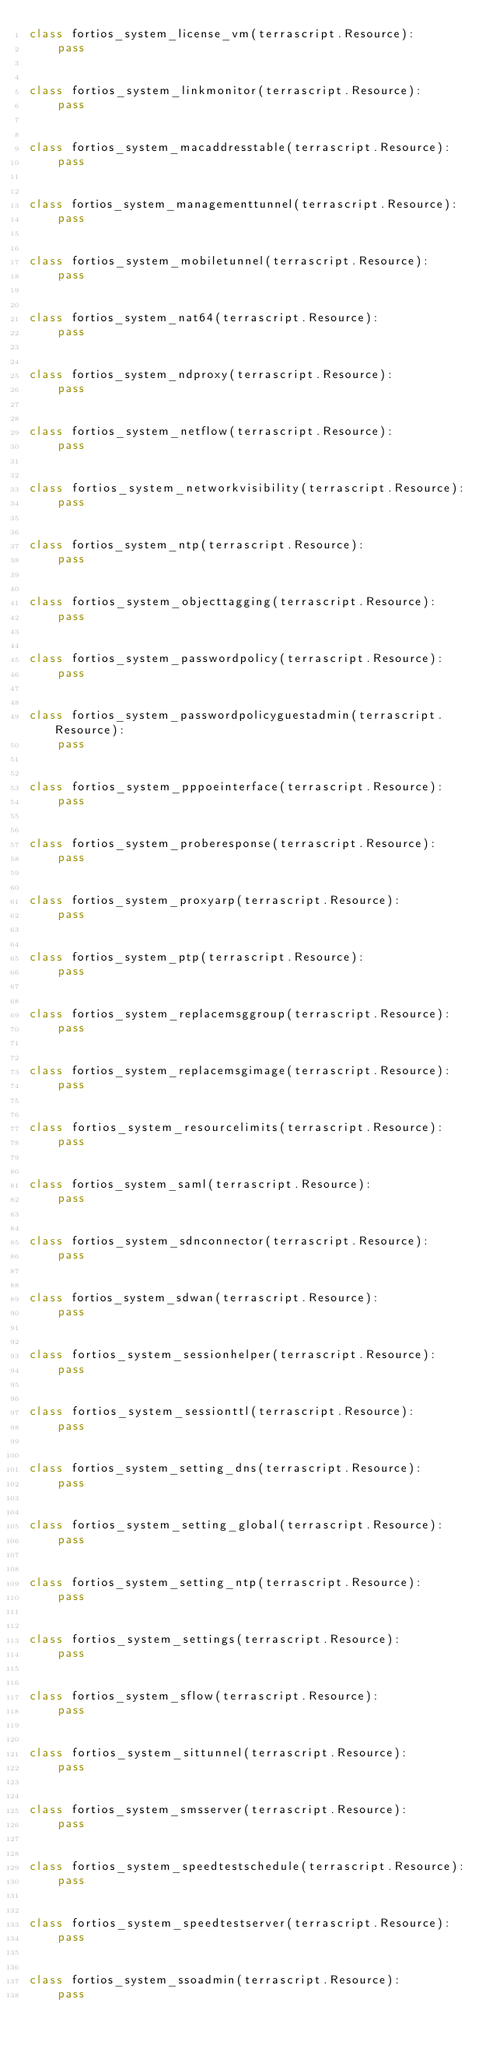<code> <loc_0><loc_0><loc_500><loc_500><_Python_>class fortios_system_license_vm(terrascript.Resource):
    pass


class fortios_system_linkmonitor(terrascript.Resource):
    pass


class fortios_system_macaddresstable(terrascript.Resource):
    pass


class fortios_system_managementtunnel(terrascript.Resource):
    pass


class fortios_system_mobiletunnel(terrascript.Resource):
    pass


class fortios_system_nat64(terrascript.Resource):
    pass


class fortios_system_ndproxy(terrascript.Resource):
    pass


class fortios_system_netflow(terrascript.Resource):
    pass


class fortios_system_networkvisibility(terrascript.Resource):
    pass


class fortios_system_ntp(terrascript.Resource):
    pass


class fortios_system_objecttagging(terrascript.Resource):
    pass


class fortios_system_passwordpolicy(terrascript.Resource):
    pass


class fortios_system_passwordpolicyguestadmin(terrascript.Resource):
    pass


class fortios_system_pppoeinterface(terrascript.Resource):
    pass


class fortios_system_proberesponse(terrascript.Resource):
    pass


class fortios_system_proxyarp(terrascript.Resource):
    pass


class fortios_system_ptp(terrascript.Resource):
    pass


class fortios_system_replacemsggroup(terrascript.Resource):
    pass


class fortios_system_replacemsgimage(terrascript.Resource):
    pass


class fortios_system_resourcelimits(terrascript.Resource):
    pass


class fortios_system_saml(terrascript.Resource):
    pass


class fortios_system_sdnconnector(terrascript.Resource):
    pass


class fortios_system_sdwan(terrascript.Resource):
    pass


class fortios_system_sessionhelper(terrascript.Resource):
    pass


class fortios_system_sessionttl(terrascript.Resource):
    pass


class fortios_system_setting_dns(terrascript.Resource):
    pass


class fortios_system_setting_global(terrascript.Resource):
    pass


class fortios_system_setting_ntp(terrascript.Resource):
    pass


class fortios_system_settings(terrascript.Resource):
    pass


class fortios_system_sflow(terrascript.Resource):
    pass


class fortios_system_sittunnel(terrascript.Resource):
    pass


class fortios_system_smsserver(terrascript.Resource):
    pass


class fortios_system_speedtestschedule(terrascript.Resource):
    pass


class fortios_system_speedtestserver(terrascript.Resource):
    pass


class fortios_system_ssoadmin(terrascript.Resource):
    pass

</code> 